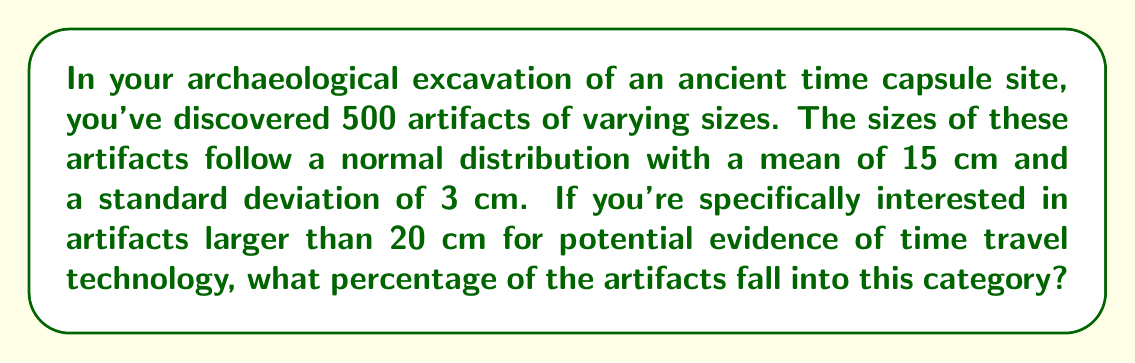Can you solve this math problem? To solve this problem, we need to use the properties of the normal distribution and find the z-score for the given value. Then, we can use a standard normal distribution table or the empirical rule to determine the percentage.

Step 1: Calculate the z-score for 20 cm.
The z-score formula is: $z = \frac{x - \mu}{\sigma}$
Where $x$ is the value of interest, $\mu$ is the mean, and $\sigma$ is the standard deviation.

$z = \frac{20 - 15}{3} = \frac{5}{3} \approx 1.67$

Step 2: Interpret the z-score.
A z-score of 1.67 means that 20 cm is 1.67 standard deviations above the mean.

Step 3: Use the empirical rule or a standard normal distribution table.
Using a standard normal distribution table, we find that approximately 0.0475 or 4.75% of the data falls above a z-score of 1.67.

Step 4: Calculate the percentage of artifacts larger than 20 cm.
The percentage we're looking for is 4.75% of the total artifacts.

$$\text{Percentage} = 4.75\% = 0.0475 \times 100\%$$
Answer: 4.75% 